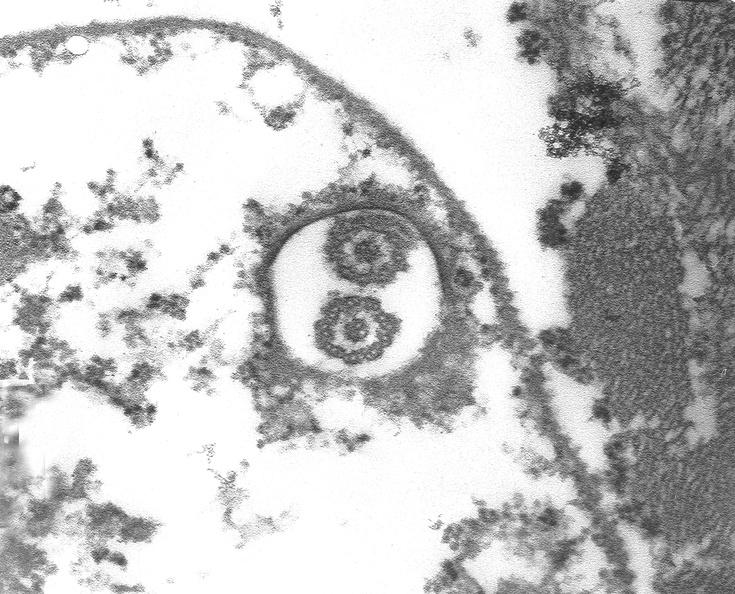does spina bifida show chagas disease, acute, trypanasoma cruzi?
Answer the question using a single word or phrase. No 